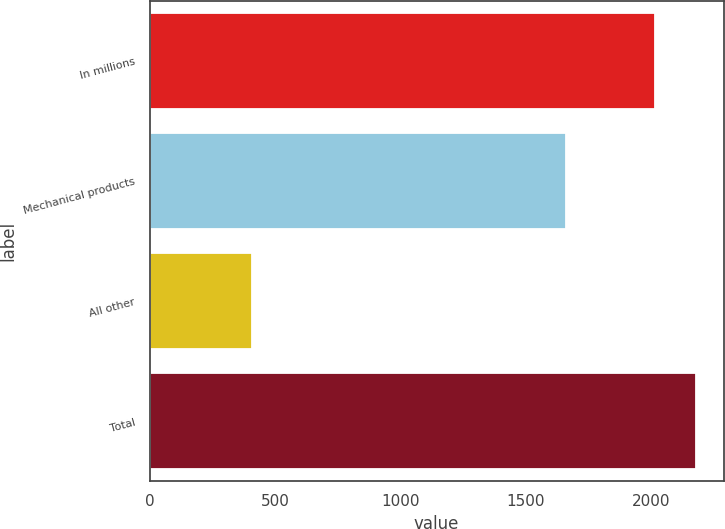Convert chart. <chart><loc_0><loc_0><loc_500><loc_500><bar_chart><fcel>In millions<fcel>Mechanical products<fcel>All other<fcel>Total<nl><fcel>2015<fcel>1661.4<fcel>406.7<fcel>2181.14<nl></chart> 